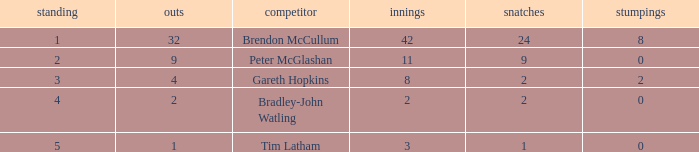How many innings had a total of 2 catches and 0 stumpings? 1.0. 